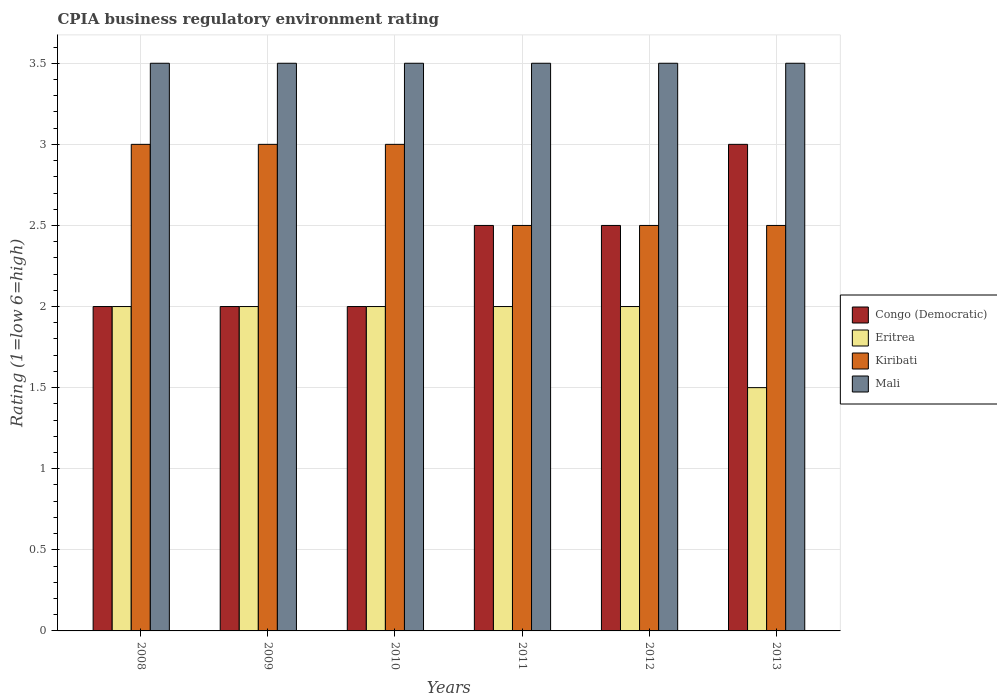How many groups of bars are there?
Keep it short and to the point. 6. Are the number of bars per tick equal to the number of legend labels?
Ensure brevity in your answer.  Yes. In how many cases, is the number of bars for a given year not equal to the number of legend labels?
Your answer should be very brief. 0. What is the CPIA rating in Congo (Democratic) in 2009?
Offer a terse response. 2. Across all years, what is the minimum CPIA rating in Congo (Democratic)?
Give a very brief answer. 2. In which year was the CPIA rating in Kiribati maximum?
Keep it short and to the point. 2008. In which year was the CPIA rating in Congo (Democratic) minimum?
Keep it short and to the point. 2008. What is the total CPIA rating in Eritrea in the graph?
Offer a terse response. 11.5. What is the difference between the CPIA rating in Mali in 2010 and that in 2012?
Make the answer very short. 0. What is the average CPIA rating in Eritrea per year?
Your response must be concise. 1.92. In the year 2008, what is the difference between the CPIA rating in Eritrea and CPIA rating in Mali?
Your answer should be very brief. -1.5. What is the difference between the highest and the second highest CPIA rating in Eritrea?
Ensure brevity in your answer.  0. What is the difference between the highest and the lowest CPIA rating in Congo (Democratic)?
Give a very brief answer. 1. What does the 4th bar from the left in 2008 represents?
Provide a short and direct response. Mali. What does the 3rd bar from the right in 2010 represents?
Provide a succinct answer. Eritrea. Is it the case that in every year, the sum of the CPIA rating in Eritrea and CPIA rating in Mali is greater than the CPIA rating in Kiribati?
Provide a succinct answer. Yes. How many bars are there?
Give a very brief answer. 24. Are all the bars in the graph horizontal?
Offer a very short reply. No. What is the difference between two consecutive major ticks on the Y-axis?
Provide a succinct answer. 0.5. Does the graph contain any zero values?
Provide a succinct answer. No. Where does the legend appear in the graph?
Keep it short and to the point. Center right. How are the legend labels stacked?
Give a very brief answer. Vertical. What is the title of the graph?
Provide a short and direct response. CPIA business regulatory environment rating. What is the label or title of the Y-axis?
Make the answer very short. Rating (1=low 6=high). What is the Rating (1=low 6=high) of Congo (Democratic) in 2008?
Give a very brief answer. 2. What is the Rating (1=low 6=high) in Eritrea in 2008?
Offer a terse response. 2. What is the Rating (1=low 6=high) of Mali in 2008?
Your response must be concise. 3.5. What is the Rating (1=low 6=high) in Eritrea in 2009?
Provide a succinct answer. 2. What is the Rating (1=low 6=high) in Congo (Democratic) in 2010?
Ensure brevity in your answer.  2. What is the Rating (1=low 6=high) of Congo (Democratic) in 2011?
Offer a terse response. 2.5. What is the Rating (1=low 6=high) of Kiribati in 2011?
Offer a very short reply. 2.5. What is the Rating (1=low 6=high) of Mali in 2011?
Offer a terse response. 3.5. What is the Rating (1=low 6=high) of Eritrea in 2012?
Keep it short and to the point. 2. What is the Rating (1=low 6=high) in Kiribati in 2013?
Your answer should be very brief. 2.5. What is the Rating (1=low 6=high) in Mali in 2013?
Your response must be concise. 3.5. Across all years, what is the maximum Rating (1=low 6=high) of Mali?
Offer a terse response. 3.5. Across all years, what is the minimum Rating (1=low 6=high) in Kiribati?
Provide a short and direct response. 2.5. Across all years, what is the minimum Rating (1=low 6=high) of Mali?
Offer a terse response. 3.5. What is the total Rating (1=low 6=high) in Eritrea in the graph?
Make the answer very short. 11.5. What is the total Rating (1=low 6=high) of Kiribati in the graph?
Your response must be concise. 16.5. What is the total Rating (1=low 6=high) in Mali in the graph?
Your answer should be compact. 21. What is the difference between the Rating (1=low 6=high) of Eritrea in 2008 and that in 2009?
Your answer should be very brief. 0. What is the difference between the Rating (1=low 6=high) of Kiribati in 2008 and that in 2009?
Offer a very short reply. 0. What is the difference between the Rating (1=low 6=high) in Congo (Democratic) in 2008 and that in 2010?
Your response must be concise. 0. What is the difference between the Rating (1=low 6=high) of Eritrea in 2008 and that in 2010?
Provide a short and direct response. 0. What is the difference between the Rating (1=low 6=high) in Congo (Democratic) in 2008 and that in 2011?
Your answer should be very brief. -0.5. What is the difference between the Rating (1=low 6=high) of Eritrea in 2008 and that in 2012?
Offer a very short reply. 0. What is the difference between the Rating (1=low 6=high) in Congo (Democratic) in 2008 and that in 2013?
Your answer should be compact. -1. What is the difference between the Rating (1=low 6=high) in Eritrea in 2008 and that in 2013?
Your answer should be very brief. 0.5. What is the difference between the Rating (1=low 6=high) in Mali in 2008 and that in 2013?
Offer a terse response. 0. What is the difference between the Rating (1=low 6=high) of Congo (Democratic) in 2009 and that in 2010?
Provide a short and direct response. 0. What is the difference between the Rating (1=low 6=high) of Kiribati in 2009 and that in 2010?
Offer a very short reply. 0. What is the difference between the Rating (1=low 6=high) in Mali in 2009 and that in 2010?
Keep it short and to the point. 0. What is the difference between the Rating (1=low 6=high) of Eritrea in 2009 and that in 2011?
Provide a short and direct response. 0. What is the difference between the Rating (1=low 6=high) of Mali in 2009 and that in 2011?
Your response must be concise. 0. What is the difference between the Rating (1=low 6=high) of Eritrea in 2009 and that in 2012?
Keep it short and to the point. 0. What is the difference between the Rating (1=low 6=high) in Kiribati in 2009 and that in 2012?
Your answer should be very brief. 0.5. What is the difference between the Rating (1=low 6=high) of Mali in 2009 and that in 2012?
Offer a very short reply. 0. What is the difference between the Rating (1=low 6=high) of Kiribati in 2009 and that in 2013?
Make the answer very short. 0.5. What is the difference between the Rating (1=low 6=high) of Eritrea in 2010 and that in 2011?
Provide a succinct answer. 0. What is the difference between the Rating (1=low 6=high) of Kiribati in 2010 and that in 2011?
Offer a terse response. 0.5. What is the difference between the Rating (1=low 6=high) of Congo (Democratic) in 2010 and that in 2012?
Your answer should be compact. -0.5. What is the difference between the Rating (1=low 6=high) of Eritrea in 2010 and that in 2012?
Offer a terse response. 0. What is the difference between the Rating (1=low 6=high) of Congo (Democratic) in 2010 and that in 2013?
Your response must be concise. -1. What is the difference between the Rating (1=low 6=high) in Kiribati in 2010 and that in 2013?
Provide a short and direct response. 0.5. What is the difference between the Rating (1=low 6=high) in Congo (Democratic) in 2011 and that in 2012?
Offer a very short reply. 0. What is the difference between the Rating (1=low 6=high) of Eritrea in 2011 and that in 2013?
Offer a very short reply. 0.5. What is the difference between the Rating (1=low 6=high) of Mali in 2011 and that in 2013?
Provide a short and direct response. 0. What is the difference between the Rating (1=low 6=high) in Eritrea in 2012 and that in 2013?
Keep it short and to the point. 0.5. What is the difference between the Rating (1=low 6=high) of Kiribati in 2012 and that in 2013?
Your answer should be very brief. 0. What is the difference between the Rating (1=low 6=high) in Congo (Democratic) in 2008 and the Rating (1=low 6=high) in Kiribati in 2009?
Provide a succinct answer. -1. What is the difference between the Rating (1=low 6=high) in Congo (Democratic) in 2008 and the Rating (1=low 6=high) in Mali in 2009?
Your response must be concise. -1.5. What is the difference between the Rating (1=low 6=high) in Eritrea in 2008 and the Rating (1=low 6=high) in Kiribati in 2010?
Offer a terse response. -1. What is the difference between the Rating (1=low 6=high) of Eritrea in 2008 and the Rating (1=low 6=high) of Mali in 2010?
Keep it short and to the point. -1.5. What is the difference between the Rating (1=low 6=high) of Kiribati in 2008 and the Rating (1=low 6=high) of Mali in 2010?
Ensure brevity in your answer.  -0.5. What is the difference between the Rating (1=low 6=high) of Congo (Democratic) in 2008 and the Rating (1=low 6=high) of Mali in 2011?
Your answer should be compact. -1.5. What is the difference between the Rating (1=low 6=high) of Eritrea in 2008 and the Rating (1=low 6=high) of Mali in 2011?
Provide a succinct answer. -1.5. What is the difference between the Rating (1=low 6=high) in Congo (Democratic) in 2008 and the Rating (1=low 6=high) in Eritrea in 2012?
Give a very brief answer. 0. What is the difference between the Rating (1=low 6=high) of Congo (Democratic) in 2008 and the Rating (1=low 6=high) of Mali in 2012?
Give a very brief answer. -1.5. What is the difference between the Rating (1=low 6=high) of Eritrea in 2008 and the Rating (1=low 6=high) of Kiribati in 2012?
Give a very brief answer. -0.5. What is the difference between the Rating (1=low 6=high) of Eritrea in 2008 and the Rating (1=low 6=high) of Mali in 2012?
Provide a succinct answer. -1.5. What is the difference between the Rating (1=low 6=high) of Congo (Democratic) in 2008 and the Rating (1=low 6=high) of Eritrea in 2013?
Your answer should be compact. 0.5. What is the difference between the Rating (1=low 6=high) in Congo (Democratic) in 2008 and the Rating (1=low 6=high) in Mali in 2013?
Provide a short and direct response. -1.5. What is the difference between the Rating (1=low 6=high) of Congo (Democratic) in 2009 and the Rating (1=low 6=high) of Mali in 2010?
Provide a short and direct response. -1.5. What is the difference between the Rating (1=low 6=high) in Kiribati in 2009 and the Rating (1=low 6=high) in Mali in 2010?
Your answer should be compact. -0.5. What is the difference between the Rating (1=low 6=high) of Congo (Democratic) in 2009 and the Rating (1=low 6=high) of Eritrea in 2011?
Your response must be concise. 0. What is the difference between the Rating (1=low 6=high) of Congo (Democratic) in 2009 and the Rating (1=low 6=high) of Mali in 2011?
Your answer should be very brief. -1.5. What is the difference between the Rating (1=low 6=high) in Congo (Democratic) in 2009 and the Rating (1=low 6=high) in Eritrea in 2012?
Make the answer very short. 0. What is the difference between the Rating (1=low 6=high) of Congo (Democratic) in 2009 and the Rating (1=low 6=high) of Kiribati in 2012?
Ensure brevity in your answer.  -0.5. What is the difference between the Rating (1=low 6=high) in Congo (Democratic) in 2009 and the Rating (1=low 6=high) in Mali in 2012?
Provide a succinct answer. -1.5. What is the difference between the Rating (1=low 6=high) of Eritrea in 2009 and the Rating (1=low 6=high) of Mali in 2012?
Offer a very short reply. -1.5. What is the difference between the Rating (1=low 6=high) in Kiribati in 2009 and the Rating (1=low 6=high) in Mali in 2012?
Give a very brief answer. -0.5. What is the difference between the Rating (1=low 6=high) of Congo (Democratic) in 2009 and the Rating (1=low 6=high) of Eritrea in 2013?
Offer a terse response. 0.5. What is the difference between the Rating (1=low 6=high) in Congo (Democratic) in 2009 and the Rating (1=low 6=high) in Kiribati in 2013?
Give a very brief answer. -0.5. What is the difference between the Rating (1=low 6=high) of Congo (Democratic) in 2009 and the Rating (1=low 6=high) of Mali in 2013?
Make the answer very short. -1.5. What is the difference between the Rating (1=low 6=high) in Eritrea in 2009 and the Rating (1=low 6=high) in Kiribati in 2013?
Provide a succinct answer. -0.5. What is the difference between the Rating (1=low 6=high) in Eritrea in 2009 and the Rating (1=low 6=high) in Mali in 2013?
Provide a succinct answer. -1.5. What is the difference between the Rating (1=low 6=high) of Kiribati in 2009 and the Rating (1=low 6=high) of Mali in 2013?
Your answer should be compact. -0.5. What is the difference between the Rating (1=low 6=high) in Congo (Democratic) in 2010 and the Rating (1=low 6=high) in Eritrea in 2011?
Keep it short and to the point. 0. What is the difference between the Rating (1=low 6=high) in Congo (Democratic) in 2010 and the Rating (1=low 6=high) in Kiribati in 2011?
Give a very brief answer. -0.5. What is the difference between the Rating (1=low 6=high) of Eritrea in 2010 and the Rating (1=low 6=high) of Kiribati in 2011?
Keep it short and to the point. -0.5. What is the difference between the Rating (1=low 6=high) in Kiribati in 2010 and the Rating (1=low 6=high) in Mali in 2011?
Offer a very short reply. -0.5. What is the difference between the Rating (1=low 6=high) in Eritrea in 2010 and the Rating (1=low 6=high) in Mali in 2012?
Your answer should be compact. -1.5. What is the difference between the Rating (1=low 6=high) in Kiribati in 2010 and the Rating (1=low 6=high) in Mali in 2012?
Provide a succinct answer. -0.5. What is the difference between the Rating (1=low 6=high) in Congo (Democratic) in 2010 and the Rating (1=low 6=high) in Eritrea in 2013?
Offer a terse response. 0.5. What is the difference between the Rating (1=low 6=high) in Eritrea in 2010 and the Rating (1=low 6=high) in Mali in 2013?
Your answer should be compact. -1.5. What is the difference between the Rating (1=low 6=high) of Kiribati in 2010 and the Rating (1=low 6=high) of Mali in 2013?
Give a very brief answer. -0.5. What is the difference between the Rating (1=low 6=high) in Congo (Democratic) in 2011 and the Rating (1=low 6=high) in Mali in 2012?
Ensure brevity in your answer.  -1. What is the difference between the Rating (1=low 6=high) of Eritrea in 2011 and the Rating (1=low 6=high) of Mali in 2012?
Your answer should be compact. -1.5. What is the difference between the Rating (1=low 6=high) of Kiribati in 2011 and the Rating (1=low 6=high) of Mali in 2012?
Provide a short and direct response. -1. What is the difference between the Rating (1=low 6=high) of Congo (Democratic) in 2011 and the Rating (1=low 6=high) of Eritrea in 2013?
Your answer should be compact. 1. What is the difference between the Rating (1=low 6=high) in Congo (Democratic) in 2011 and the Rating (1=low 6=high) in Kiribati in 2013?
Make the answer very short. 0. What is the difference between the Rating (1=low 6=high) of Congo (Democratic) in 2011 and the Rating (1=low 6=high) of Mali in 2013?
Make the answer very short. -1. What is the difference between the Rating (1=low 6=high) in Eritrea in 2011 and the Rating (1=low 6=high) in Kiribati in 2013?
Provide a succinct answer. -0.5. What is the difference between the Rating (1=low 6=high) of Kiribati in 2011 and the Rating (1=low 6=high) of Mali in 2013?
Your answer should be very brief. -1. What is the difference between the Rating (1=low 6=high) of Congo (Democratic) in 2012 and the Rating (1=low 6=high) of Kiribati in 2013?
Offer a very short reply. 0. What is the average Rating (1=low 6=high) in Congo (Democratic) per year?
Provide a succinct answer. 2.33. What is the average Rating (1=low 6=high) in Eritrea per year?
Offer a terse response. 1.92. What is the average Rating (1=low 6=high) of Kiribati per year?
Ensure brevity in your answer.  2.75. In the year 2008, what is the difference between the Rating (1=low 6=high) of Congo (Democratic) and Rating (1=low 6=high) of Eritrea?
Offer a very short reply. 0. In the year 2008, what is the difference between the Rating (1=low 6=high) of Eritrea and Rating (1=low 6=high) of Kiribati?
Your answer should be compact. -1. In the year 2008, what is the difference between the Rating (1=low 6=high) of Eritrea and Rating (1=low 6=high) of Mali?
Your answer should be compact. -1.5. In the year 2009, what is the difference between the Rating (1=low 6=high) of Congo (Democratic) and Rating (1=low 6=high) of Eritrea?
Keep it short and to the point. 0. In the year 2009, what is the difference between the Rating (1=low 6=high) in Congo (Democratic) and Rating (1=low 6=high) in Kiribati?
Your answer should be very brief. -1. In the year 2009, what is the difference between the Rating (1=low 6=high) in Congo (Democratic) and Rating (1=low 6=high) in Mali?
Offer a terse response. -1.5. In the year 2009, what is the difference between the Rating (1=low 6=high) in Eritrea and Rating (1=low 6=high) in Kiribati?
Your answer should be very brief. -1. In the year 2010, what is the difference between the Rating (1=low 6=high) in Congo (Democratic) and Rating (1=low 6=high) in Eritrea?
Offer a very short reply. 0. In the year 2010, what is the difference between the Rating (1=low 6=high) in Congo (Democratic) and Rating (1=low 6=high) in Mali?
Provide a succinct answer. -1.5. In the year 2010, what is the difference between the Rating (1=low 6=high) in Eritrea and Rating (1=low 6=high) in Kiribati?
Your answer should be very brief. -1. In the year 2010, what is the difference between the Rating (1=low 6=high) of Eritrea and Rating (1=low 6=high) of Mali?
Provide a succinct answer. -1.5. In the year 2010, what is the difference between the Rating (1=low 6=high) in Kiribati and Rating (1=low 6=high) in Mali?
Provide a succinct answer. -0.5. In the year 2011, what is the difference between the Rating (1=low 6=high) of Congo (Democratic) and Rating (1=low 6=high) of Eritrea?
Provide a short and direct response. 0.5. In the year 2011, what is the difference between the Rating (1=low 6=high) of Congo (Democratic) and Rating (1=low 6=high) of Kiribati?
Make the answer very short. 0. In the year 2011, what is the difference between the Rating (1=low 6=high) of Eritrea and Rating (1=low 6=high) of Mali?
Make the answer very short. -1.5. In the year 2011, what is the difference between the Rating (1=low 6=high) of Kiribati and Rating (1=low 6=high) of Mali?
Provide a succinct answer. -1. In the year 2012, what is the difference between the Rating (1=low 6=high) of Congo (Democratic) and Rating (1=low 6=high) of Mali?
Keep it short and to the point. -1. In the year 2012, what is the difference between the Rating (1=low 6=high) of Eritrea and Rating (1=low 6=high) of Kiribati?
Make the answer very short. -0.5. In the year 2012, what is the difference between the Rating (1=low 6=high) in Eritrea and Rating (1=low 6=high) in Mali?
Ensure brevity in your answer.  -1.5. In the year 2013, what is the difference between the Rating (1=low 6=high) of Eritrea and Rating (1=low 6=high) of Kiribati?
Provide a short and direct response. -1. In the year 2013, what is the difference between the Rating (1=low 6=high) of Eritrea and Rating (1=low 6=high) of Mali?
Offer a very short reply. -2. What is the ratio of the Rating (1=low 6=high) of Eritrea in 2008 to that in 2009?
Your response must be concise. 1. What is the ratio of the Rating (1=low 6=high) of Congo (Democratic) in 2008 to that in 2010?
Your answer should be very brief. 1. What is the ratio of the Rating (1=low 6=high) in Eritrea in 2008 to that in 2010?
Give a very brief answer. 1. What is the ratio of the Rating (1=low 6=high) of Kiribati in 2008 to that in 2010?
Your response must be concise. 1. What is the ratio of the Rating (1=low 6=high) in Mali in 2008 to that in 2011?
Your response must be concise. 1. What is the ratio of the Rating (1=low 6=high) in Eritrea in 2008 to that in 2012?
Make the answer very short. 1. What is the ratio of the Rating (1=low 6=high) in Mali in 2008 to that in 2013?
Make the answer very short. 1. What is the ratio of the Rating (1=low 6=high) in Kiribati in 2009 to that in 2010?
Ensure brevity in your answer.  1. What is the ratio of the Rating (1=low 6=high) of Mali in 2009 to that in 2010?
Give a very brief answer. 1. What is the ratio of the Rating (1=low 6=high) in Congo (Democratic) in 2009 to that in 2011?
Make the answer very short. 0.8. What is the ratio of the Rating (1=low 6=high) of Eritrea in 2009 to that in 2011?
Ensure brevity in your answer.  1. What is the ratio of the Rating (1=low 6=high) in Congo (Democratic) in 2009 to that in 2012?
Offer a very short reply. 0.8. What is the ratio of the Rating (1=low 6=high) of Kiribati in 2009 to that in 2012?
Ensure brevity in your answer.  1.2. What is the ratio of the Rating (1=low 6=high) in Eritrea in 2009 to that in 2013?
Provide a short and direct response. 1.33. What is the ratio of the Rating (1=low 6=high) in Kiribati in 2009 to that in 2013?
Your response must be concise. 1.2. What is the ratio of the Rating (1=low 6=high) of Mali in 2010 to that in 2012?
Your response must be concise. 1. What is the ratio of the Rating (1=low 6=high) in Congo (Democratic) in 2010 to that in 2013?
Ensure brevity in your answer.  0.67. What is the ratio of the Rating (1=low 6=high) in Eritrea in 2010 to that in 2013?
Keep it short and to the point. 1.33. What is the ratio of the Rating (1=low 6=high) of Congo (Democratic) in 2011 to that in 2012?
Offer a terse response. 1. What is the ratio of the Rating (1=low 6=high) of Kiribati in 2012 to that in 2013?
Keep it short and to the point. 1. What is the ratio of the Rating (1=low 6=high) of Mali in 2012 to that in 2013?
Your answer should be very brief. 1. What is the difference between the highest and the second highest Rating (1=low 6=high) in Kiribati?
Keep it short and to the point. 0. What is the difference between the highest and the second highest Rating (1=low 6=high) of Mali?
Offer a very short reply. 0. What is the difference between the highest and the lowest Rating (1=low 6=high) in Eritrea?
Your answer should be compact. 0.5. What is the difference between the highest and the lowest Rating (1=low 6=high) in Mali?
Give a very brief answer. 0. 